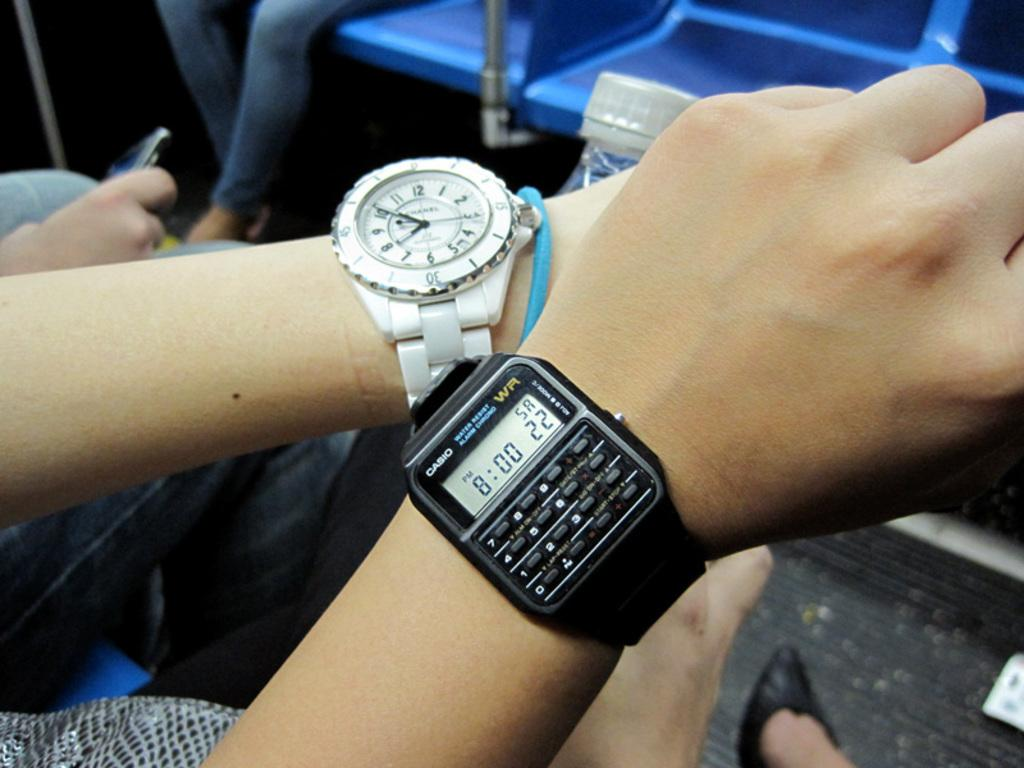<image>
Relay a brief, clear account of the picture shown. A Casio watch displays the time of 8:00 pm. 